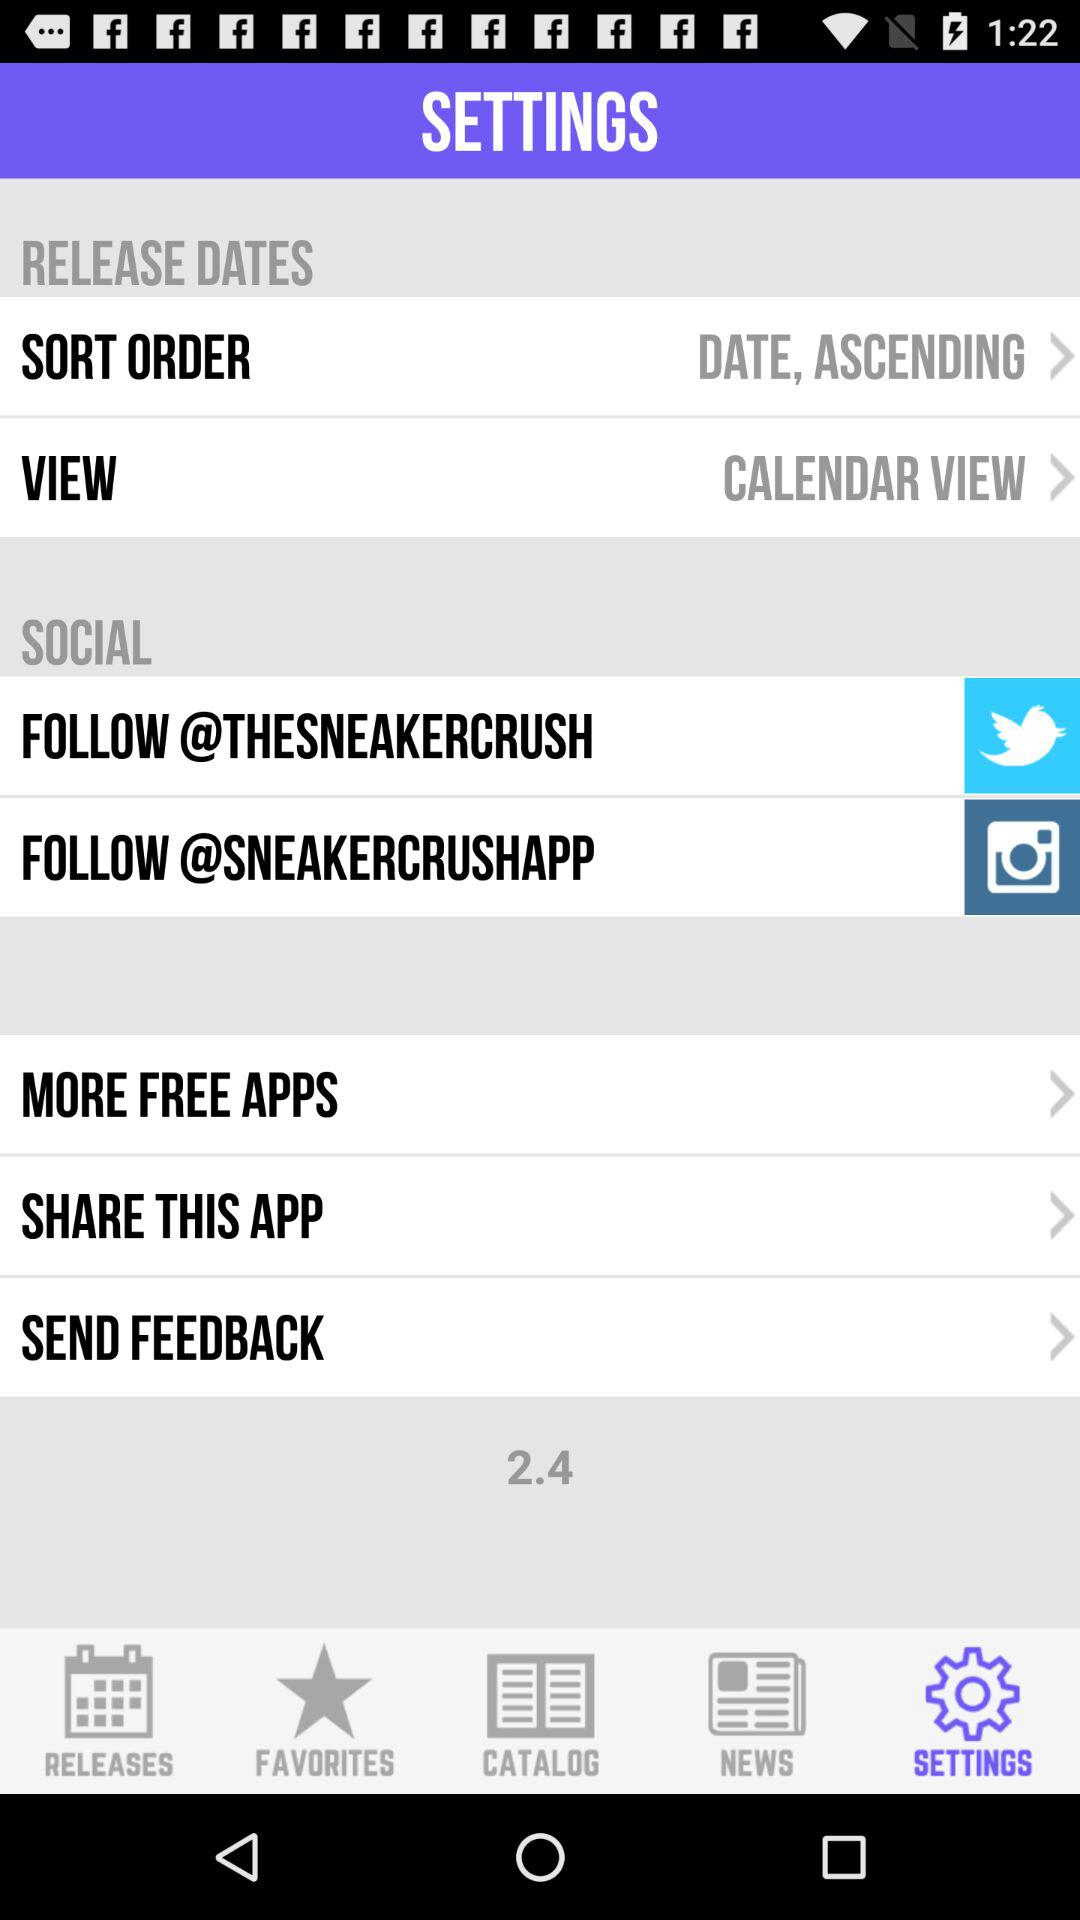What is the selected sort order? The selected sort order is "DATE, ASCENDING". 